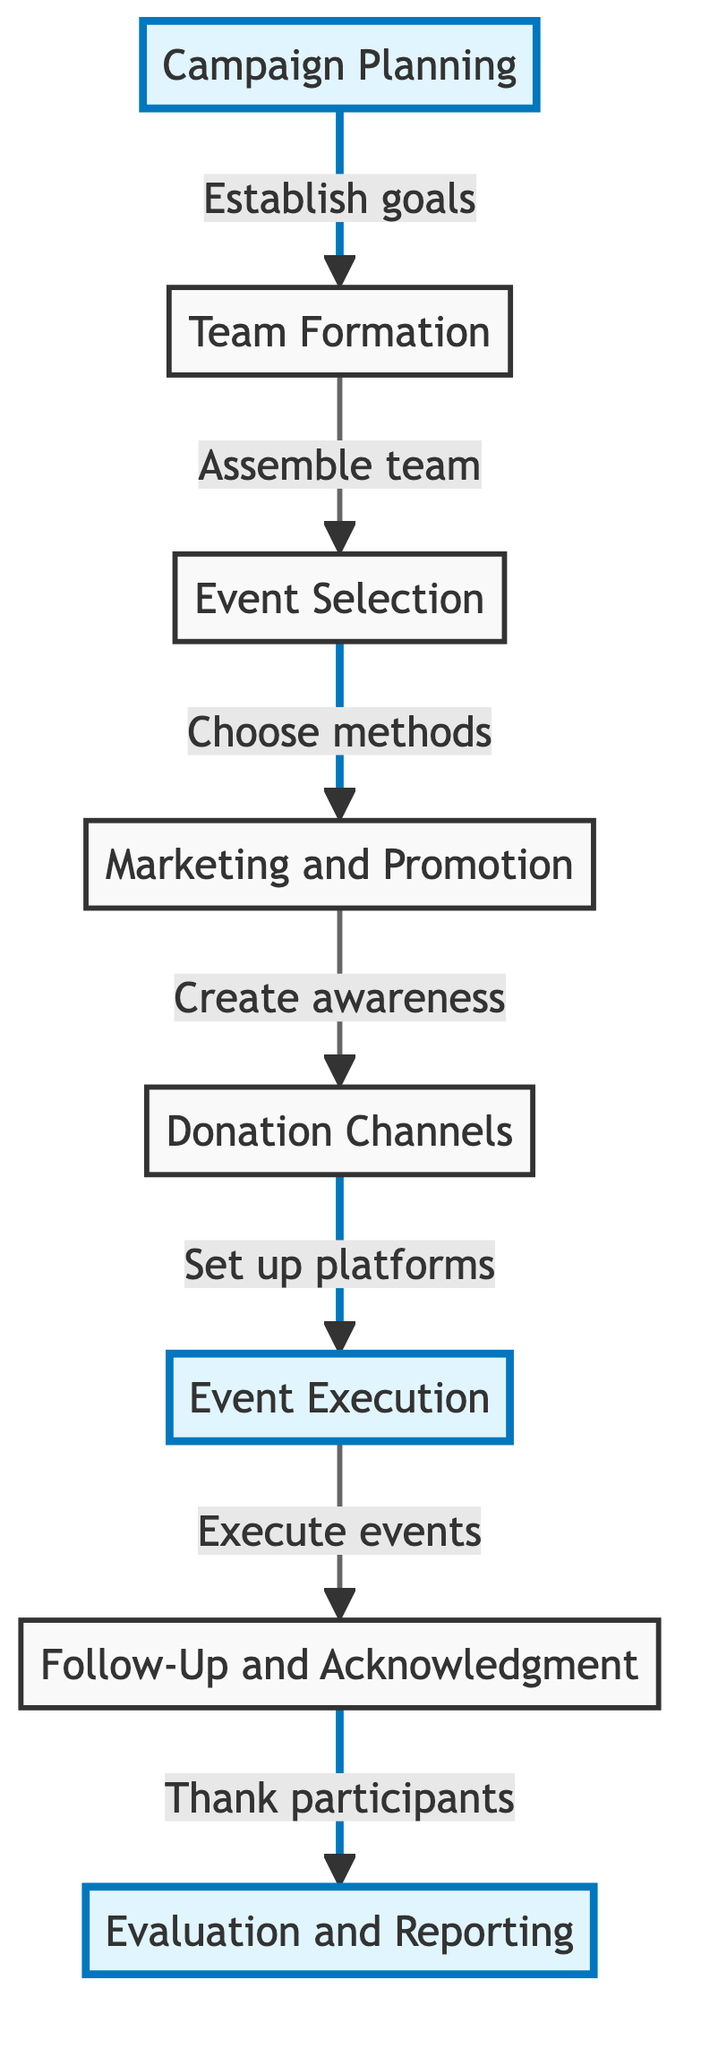What's the total number of nodes in the diagram? The diagram contains eight nodes which include Campaign Planning, Team Formation, Event Selection, Marketing and Promotion, Donation Channels, Event Execution, Follow-Up and Acknowledgment, and Evaluation and Reporting.
Answer: Eight What is the last node in the flow of the campaign? After following the flow from the starting node (Campaign Planning) through Team Formation, Event Selection, Marketing and Promotion, Donation Channels, Event Execution, and Follow-Up and Acknowledgment, the flow concludes at Evaluation and Reporting.
Answer: Evaluation and Reporting Which node executes the planned fundraising events? Event Execution is the node responsible for carrying out the activities scheduled for the fundraising events as indicated in the diagram.
Answer: Event Execution What is the relationship between "Event Selection" and "Marketing and Promotion"? Event Selection leads directly to Marketing and Promotion, meaning the choice of fundraising methods is a prerequisite for creating awareness about the campaigns.
Answer: Leads to How many edges are there in total connecting the nodes? There are seven edges connecting the nodes, representing the directed links from one step to the next in the fundraising campaign structure.
Answer: Seven What role does the "Follow-Up and Acknowledgment" node play in the fundraising process? The Follow-Up and Acknowledgment node is responsible for thanking donors and participants as well as providing a campaign impact report after the events are executed, highlighting its importance in donor relations.
Answer: Thanking donors Which node precedes the "Donation Channels" node? The Marketing and Promotion node directly precedes the Donation Channels node in the sequence, indicating that creating awareness is necessary before setting up donation platforms.
Answer: Marketing and Promotion What does the arrow direction between "Team Formation" and "Event Selection" indicate? The arrow from Team Formation to Event Selection signifies that once the team is assembled, the next step is to select the fundraising events or approaches for the campaign.
Answer: Indicates the next step What is the primary purpose of the "Evaluation and Reporting" node? The Evaluation and Reporting node serves to assess the campaign's success and document outcomes, which is essential for understanding the impact and guiding future campaigns.
Answer: Assessing success 